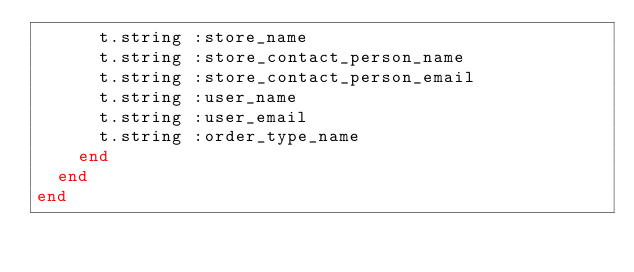Convert code to text. <code><loc_0><loc_0><loc_500><loc_500><_Ruby_>      t.string :store_name
      t.string :store_contact_person_name
      t.string :store_contact_person_email
      t.string :user_name
      t.string :user_email
      t.string :order_type_name
    end
  end
end
</code> 